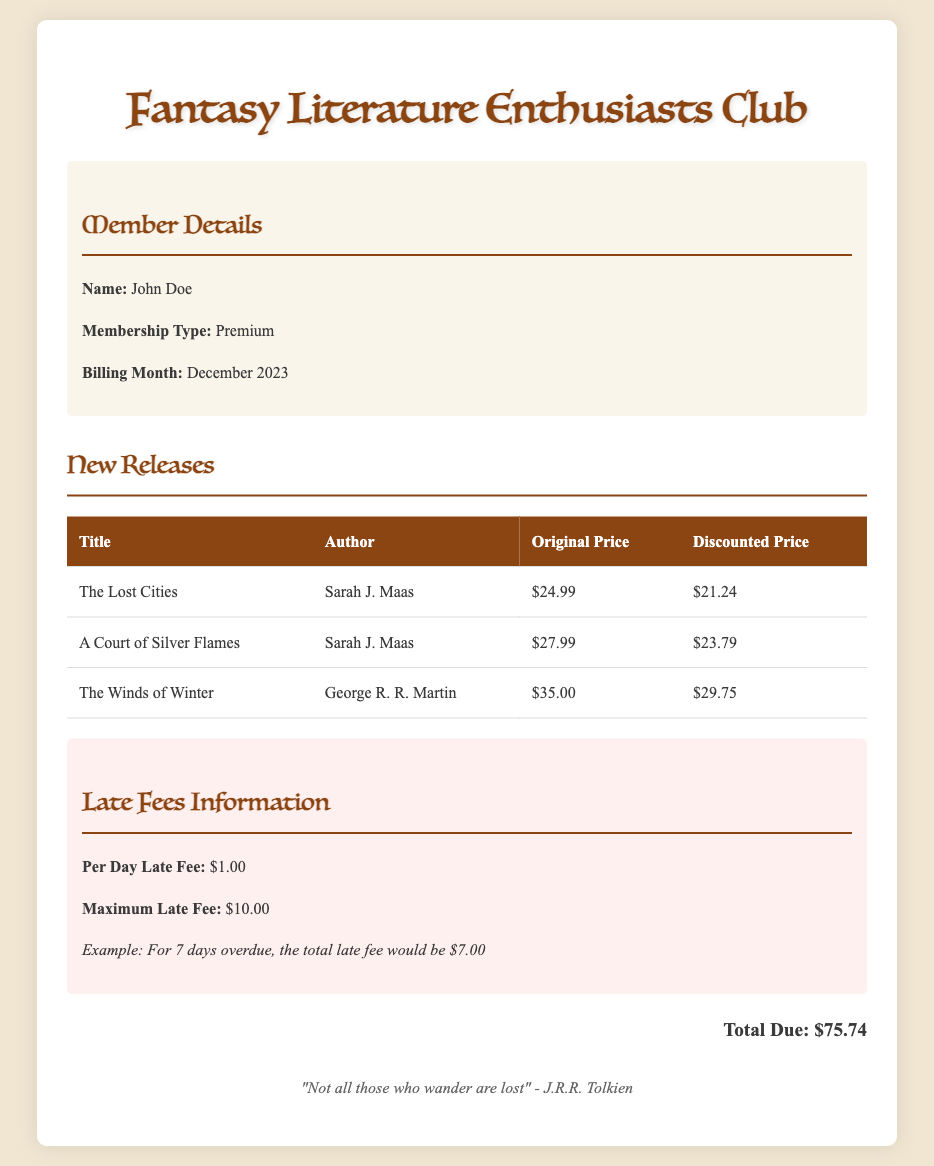What is the name of the author for "The Lost Cities"? The document lists Sarah J. Maas as the author of "The Lost Cities".
Answer: Sarah J. Maas What is the maximum late fee? The document specifies that the maximum late fee is $10.00.
Answer: $10.00 What is the discounted price of "A Court of Silver Flames"? The bill indicates that the discounted price for "A Court of Silver Flames" is $23.79.
Answer: $23.79 How many new releases are listed? The document presents three new releases in the table section.
Answer: 3 What is the per day late fee? According to the document, the per day late fee is $1.00.
Answer: $1.00 What is the total due amount? The total due amount stated in the bill is $75.74.
Answer: $75.74 What is the membership type of the member? The member's type stated in the document is Premium.
Answer: Premium What is the title of the book by George R. R. Martin? The document mentions "The Winds of Winter" as the title of the book by George R. R. Martin.
Answer: The Winds of Winter 